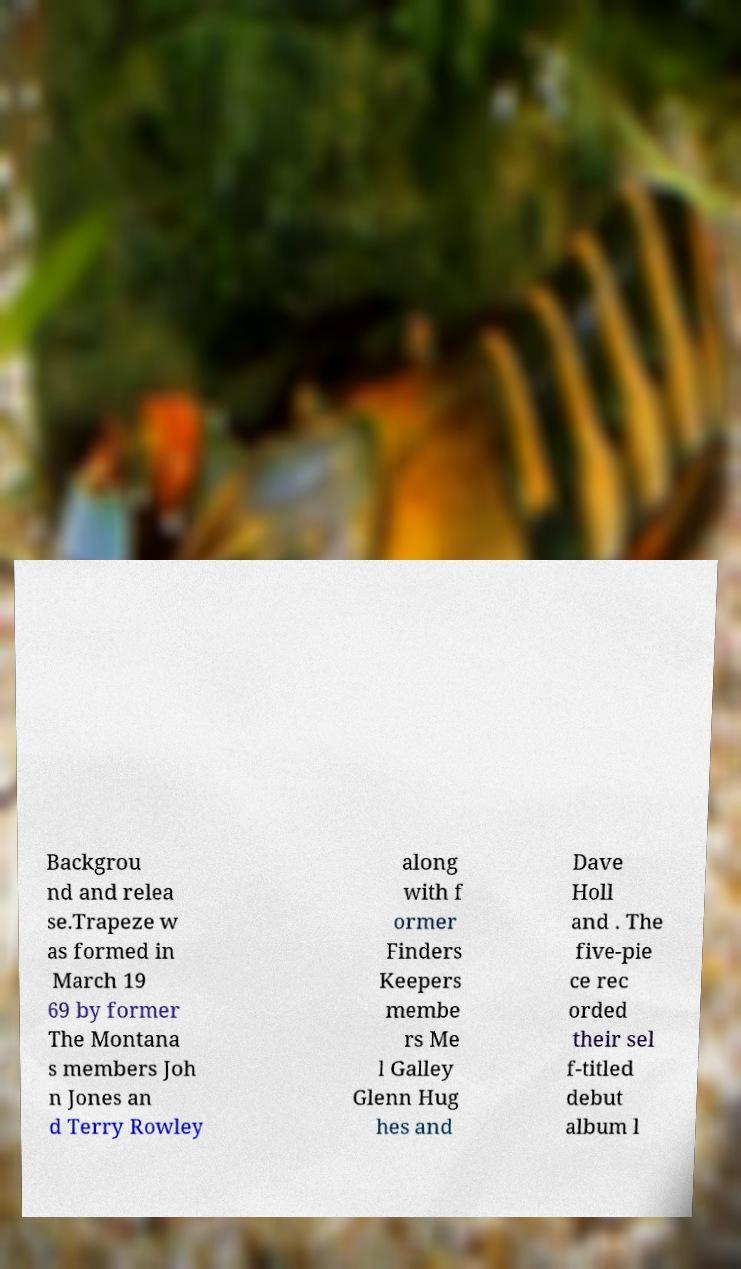Could you assist in decoding the text presented in this image and type it out clearly? Backgrou nd and relea se.Trapeze w as formed in March 19 69 by former The Montana s members Joh n Jones an d Terry Rowley along with f ormer Finders Keepers membe rs Me l Galley Glenn Hug hes and Dave Holl and . The five-pie ce rec orded their sel f-titled debut album l 